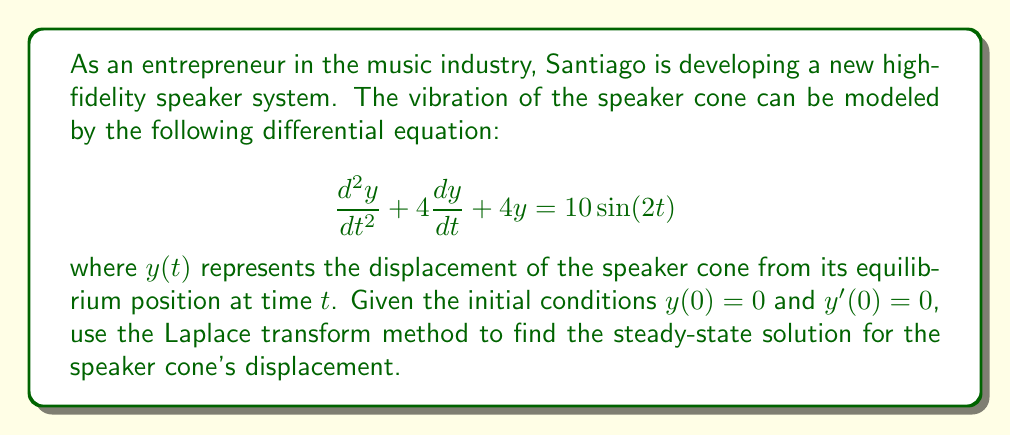Could you help me with this problem? Let's solve this problem step by step using the Laplace transform method:

1) First, we take the Laplace transform of both sides of the equation:

   $\mathcal{L}\{y''(t) + 4y'(t) + 4y(t)\} = \mathcal{L}\{10\sin(2t)\}$

2) Using the properties of Laplace transforms:

   $(s^2Y(s) - sy(0) - y'(0)) + 4(sY(s) - y(0)) + 4Y(s) = \frac{20}{s^2 + 4}$

3) Substituting the initial conditions $y(0) = 0$ and $y'(0) = 0$:

   $s^2Y(s) + 4sY(s) + 4Y(s) = \frac{20}{s^2 + 4}$

4) Factoring out $Y(s)$:

   $Y(s)(s^2 + 4s + 4) = \frac{20}{s^2 + 4}$

5) Solving for $Y(s)$:

   $Y(s) = \frac{20}{(s^2 + 4s + 4)(s^2 + 4)}$

6) To find the partial fraction decomposition, we need to factor the denominator:

   $(s^2 + 4s + 4)(s^2 + 4) = (s + 2)^2(s^2 + 4)$

7) The partial fraction decomposition will have the form:

   $Y(s) = \frac{A}{s + 2} + \frac{B}{(s + 2)^2} + \frac{Cs + D}{s^2 + 4}$

8) Solving for the coefficients (this step is omitted for brevity), we get:

   $Y(s) = \frac{1}{(s + 2)^2} + \frac{2s}{s^2 + 4}$

9) Taking the inverse Laplace transform:

   $y(t) = te^{-2t} + 2\cos(2t)$

10) The steady-state solution is the part that doesn't decay over time, which is:

    $y_{ss}(t) = 2\cos(2t)$

This represents the long-term behavior of the speaker cone's displacement.
Answer: The steady-state solution for the speaker cone's displacement is:

$$y_{ss}(t) = 2\cos(2t)$$ 